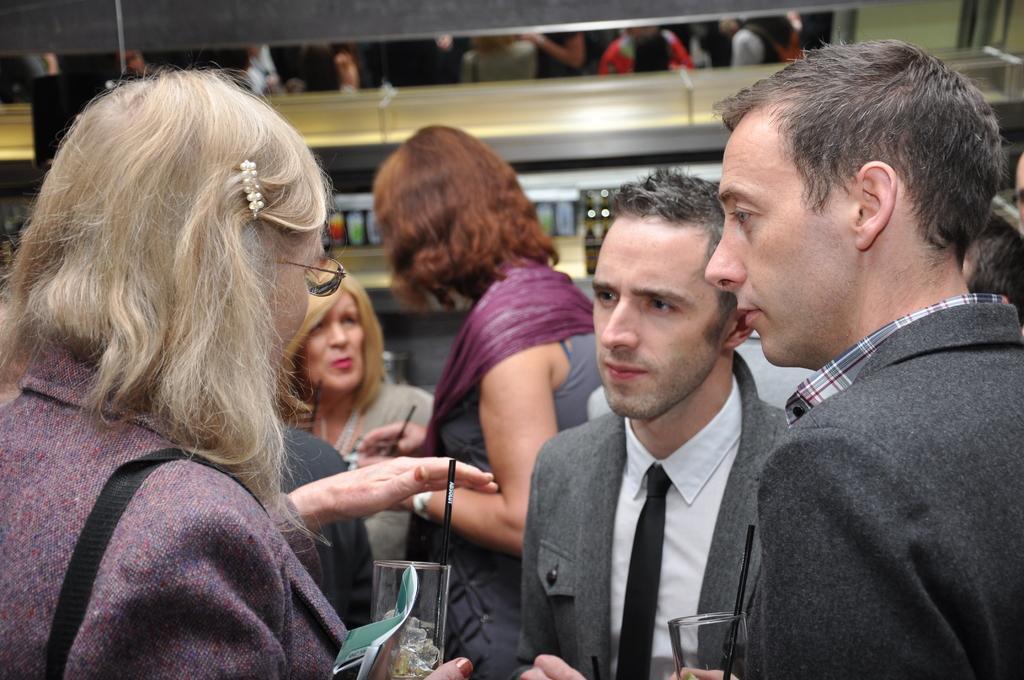Please provide a concise description of this image. In this image we can see people standing and holding glasses. In the background there is a wall. 